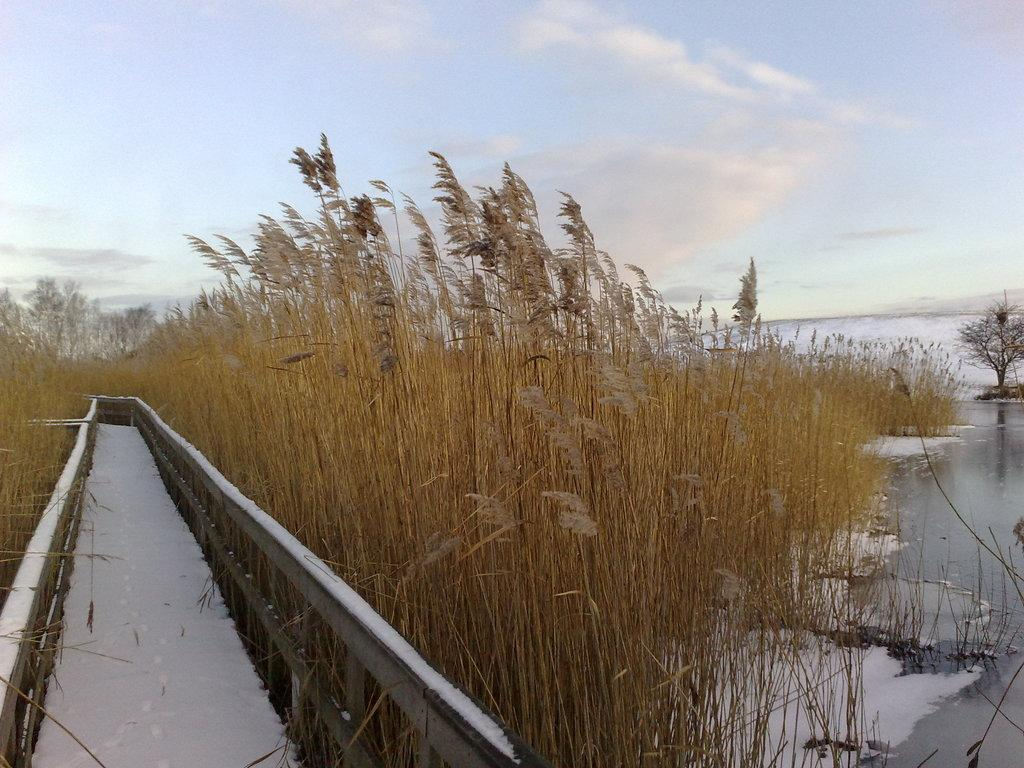What is the main feature in the image? There is a path in the image. What can be seen around the path? The path is surrounded by plants. What body of water is visible in the image? There is a lake on the right side of the image. What is visible in the background of the image? The sky is visible in the background of the image. How many nails are used to hold the wooden fence in the image? There is no wooden fence present in the image, so it is not possible to determine the number of nails used. 